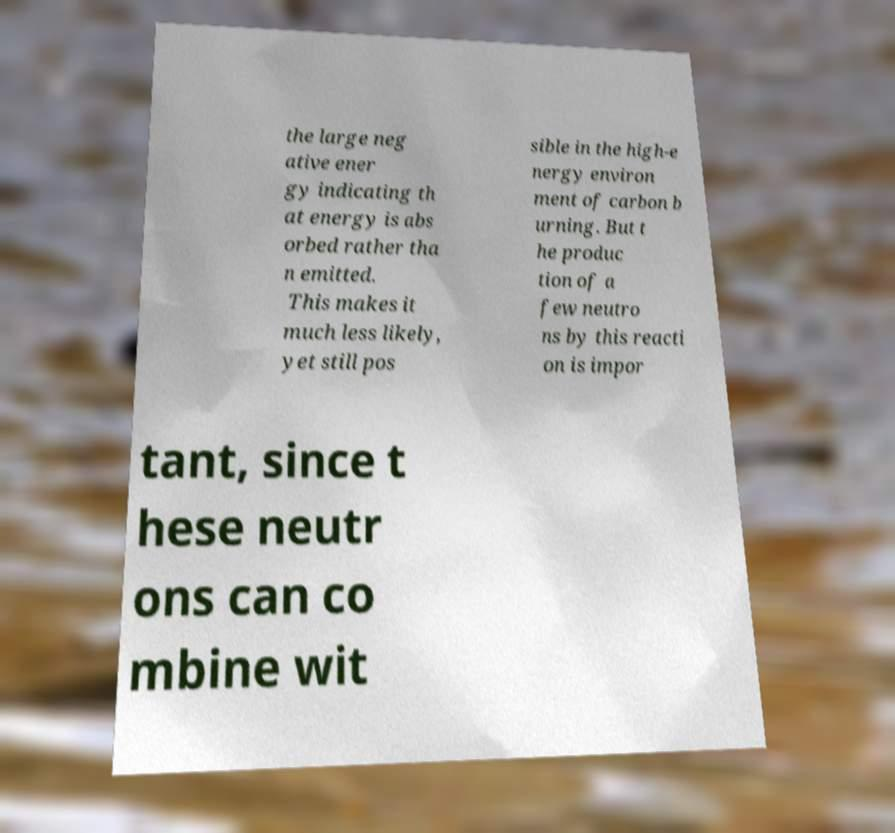I need the written content from this picture converted into text. Can you do that? the large neg ative ener gy indicating th at energy is abs orbed rather tha n emitted. This makes it much less likely, yet still pos sible in the high-e nergy environ ment of carbon b urning. But t he produc tion of a few neutro ns by this reacti on is impor tant, since t hese neutr ons can co mbine wit 